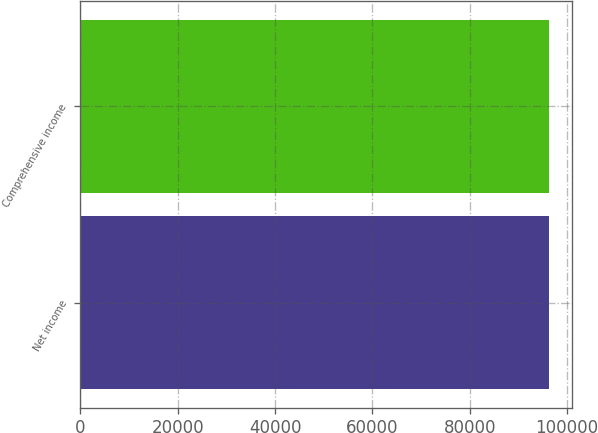Convert chart to OTSL. <chart><loc_0><loc_0><loc_500><loc_500><bar_chart><fcel>Net income<fcel>Comprehensive income<nl><fcel>96241<fcel>96263<nl></chart> 